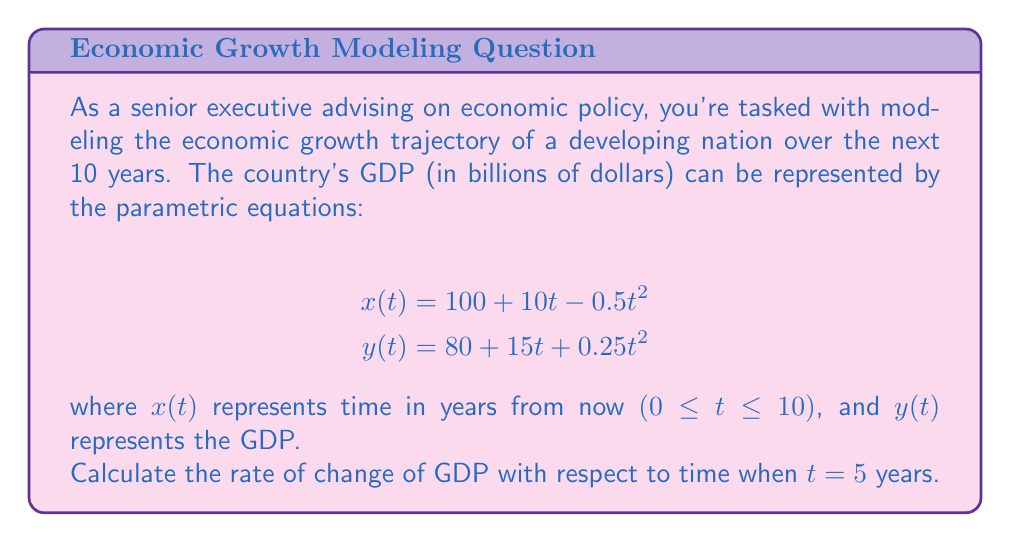Give your solution to this math problem. To solve this problem, we need to follow these steps:

1) First, we need to find $\frac{dy}{dt}$ and $\frac{dx}{dt}$ using the chain rule:

   $$\frac{dy}{dt} = 15 + 0.5t$$
   $$\frac{dx}{dt} = 10 - t$$

2) The rate of change of GDP with respect to time is given by $\frac{dy}{dx}$. We can find this using the chain rule:

   $$\frac{dy}{dx} = \frac{dy/dt}{dx/dt} = \frac{15 + 0.5t}{10 - t}$$

3) Now, we need to evaluate this at $t = 5$:

   $$\frac{dy}{dx}\bigg|_{t=5} = \frac{15 + 0.5(5)}{10 - 5} = \frac{17.5}{5} = 3.5$$

Therefore, the rate of change of GDP with respect to time when $t = 5$ years is 3.5 billion dollars per year.
Answer: 3.5 billion dollars per year 